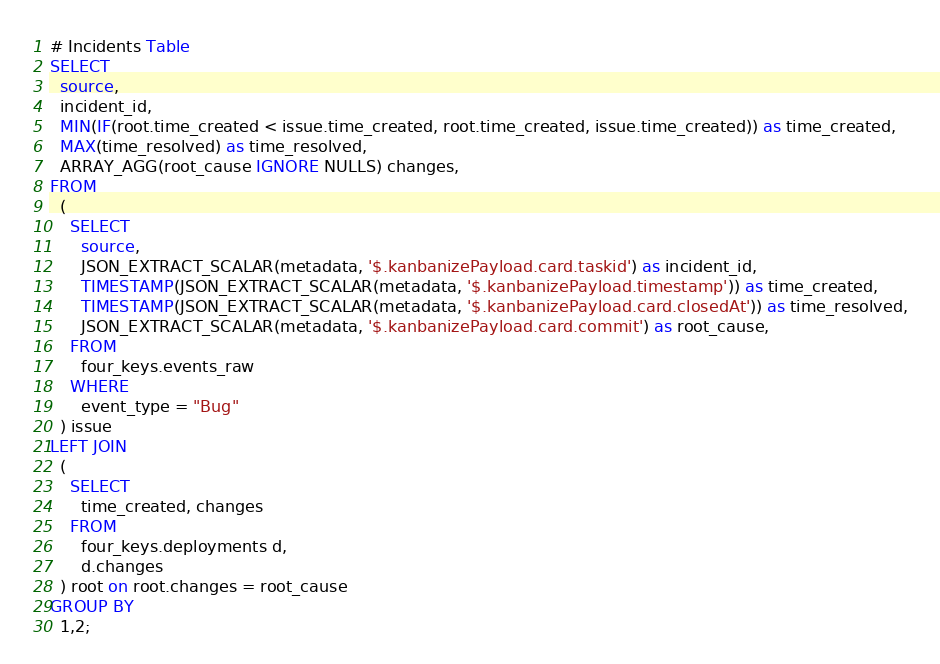Convert code to text. <code><loc_0><loc_0><loc_500><loc_500><_SQL_># Incidents Table
SELECT
  source,
  incident_id,
  MIN(IF(root.time_created < issue.time_created, root.time_created, issue.time_created)) as time_created,
  MAX(time_resolved) as time_resolved,
  ARRAY_AGG(root_cause IGNORE NULLS) changes,
FROM
  (
    SELECT 
      source,
      JSON_EXTRACT_SCALAR(metadata, '$.kanbanizePayload.card.taskid') as incident_id,
      TIMESTAMP(JSON_EXTRACT_SCALAR(metadata, '$.kanbanizePayload.timestamp')) as time_created,
      TIMESTAMP(JSON_EXTRACT_SCALAR(metadata, '$.kanbanizePayload.card.closedAt')) as time_resolved,
      JSON_EXTRACT_SCALAR(metadata, '$.kanbanizePayload.card.commit') as root_cause,
    FROM 
      four_keys.events_raw 
    WHERE 
      event_type = "Bug" 
  ) issue
LEFT JOIN 
  (
    SELECT 
      time_created, changes 
    FROM 
      four_keys.deployments d, 
      d.changes
  ) root on root.changes = root_cause
GROUP BY 
  1,2;</code> 